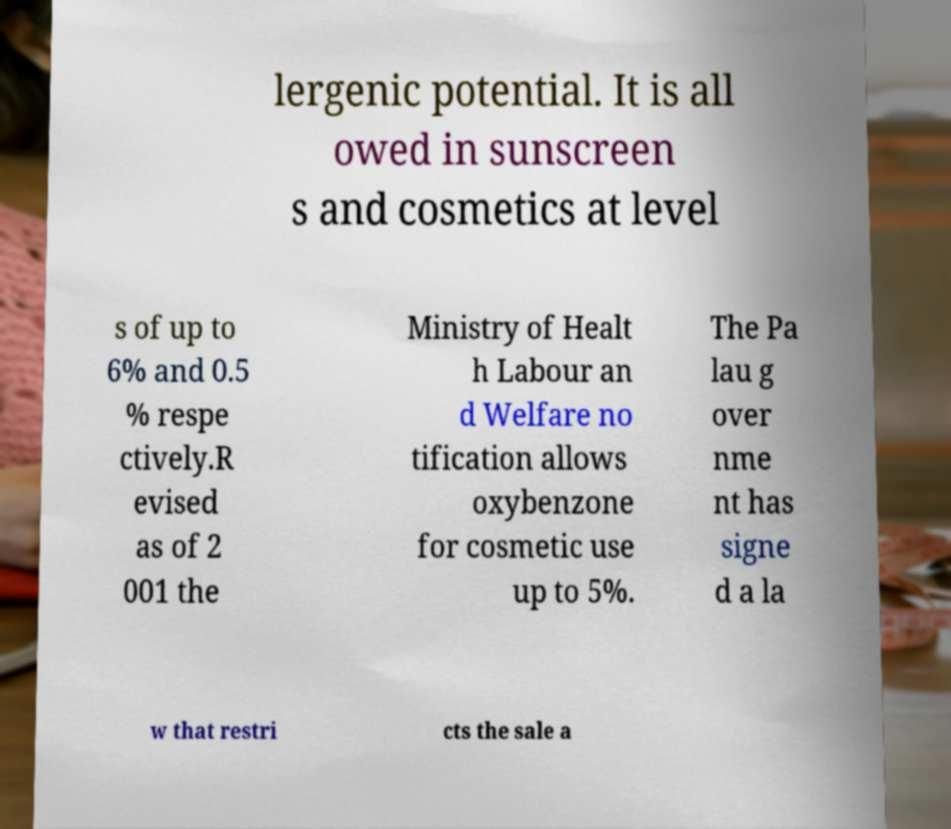Could you assist in decoding the text presented in this image and type it out clearly? lergenic potential. It is all owed in sunscreen s and cosmetics at level s of up to 6% and 0.5 % respe ctively.R evised as of 2 001 the Ministry of Healt h Labour an d Welfare no tification allows oxybenzone for cosmetic use up to 5%. The Pa lau g over nme nt has signe d a la w that restri cts the sale a 